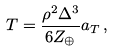<formula> <loc_0><loc_0><loc_500><loc_500>T = \frac { \rho ^ { 2 } \Delta ^ { 3 } } { 6 Z _ { \oplus } } a _ { T } \, ,</formula> 